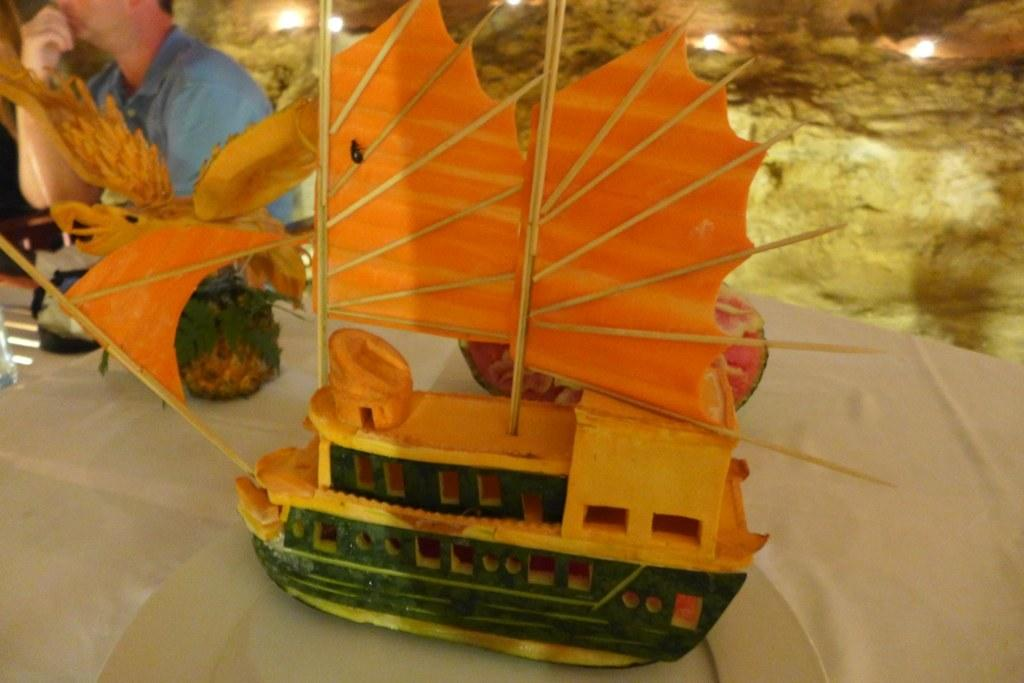What is the main subject of the image? The main subject of the image is a toy boat made with fruits. What is the toy boat placed on? The toy boat is on a cloth. Can you describe the person in the image? Unfortunately, there is no information about the person in the image. What letters are visible on the table in the image? There is no table or letters present in the image. How many feet can be seen on the person in the image? There is no person or feet visible in the image. 